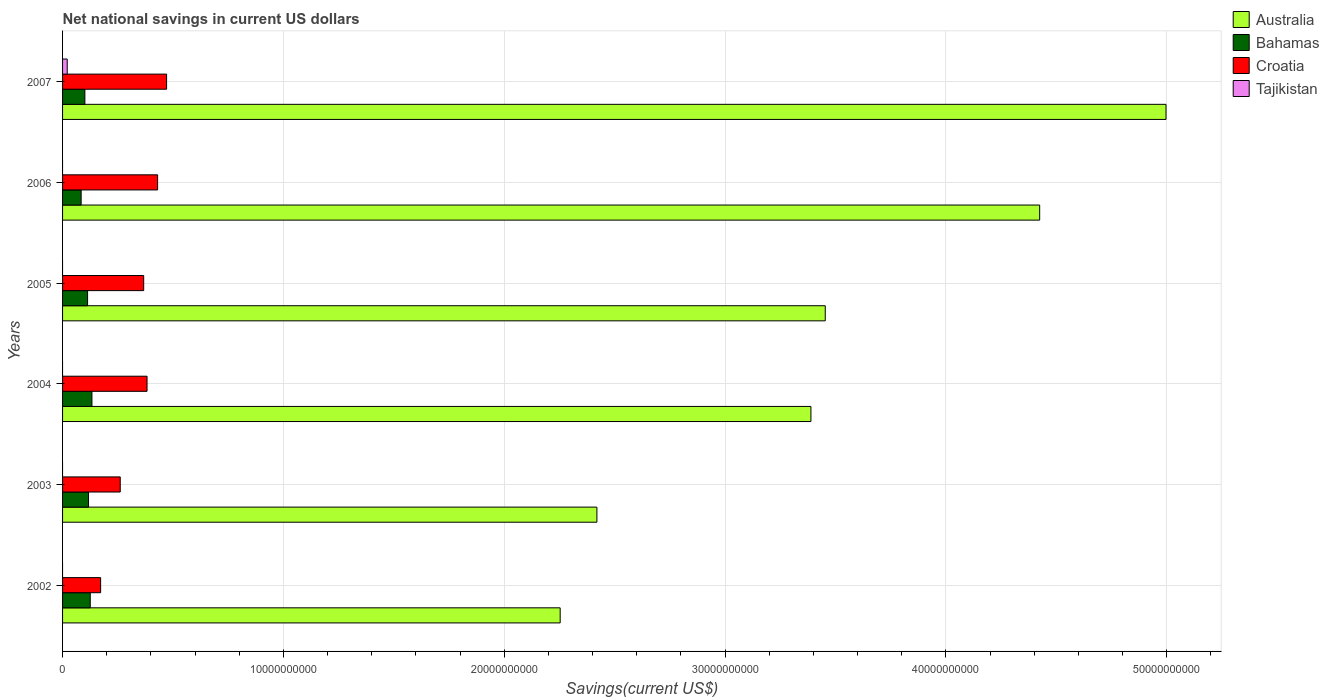Are the number of bars per tick equal to the number of legend labels?
Ensure brevity in your answer.  No. Are the number of bars on each tick of the Y-axis equal?
Offer a terse response. No. How many bars are there on the 4th tick from the top?
Offer a terse response. 3. How many bars are there on the 1st tick from the bottom?
Your answer should be very brief. 3. What is the label of the 5th group of bars from the top?
Provide a succinct answer. 2003. What is the net national savings in Croatia in 2007?
Give a very brief answer. 4.71e+09. Across all years, what is the maximum net national savings in Bahamas?
Provide a short and direct response. 1.33e+09. Across all years, what is the minimum net national savings in Bahamas?
Your answer should be very brief. 8.41e+08. In which year was the net national savings in Tajikistan maximum?
Keep it short and to the point. 2007. What is the total net national savings in Croatia in the graph?
Your answer should be very brief. 2.08e+1. What is the difference between the net national savings in Australia in 2002 and that in 2004?
Your answer should be very brief. -1.14e+1. What is the difference between the net national savings in Tajikistan in 2004 and the net national savings in Croatia in 2002?
Make the answer very short. -1.72e+09. What is the average net national savings in Tajikistan per year?
Your answer should be very brief. 3.51e+07. In the year 2004, what is the difference between the net national savings in Bahamas and net national savings in Australia?
Ensure brevity in your answer.  -3.26e+1. What is the ratio of the net national savings in Australia in 2003 to that in 2004?
Provide a succinct answer. 0.71. Is the difference between the net national savings in Bahamas in 2006 and 2007 greater than the difference between the net national savings in Australia in 2006 and 2007?
Make the answer very short. Yes. What is the difference between the highest and the second highest net national savings in Croatia?
Your response must be concise. 4.07e+08. What is the difference between the highest and the lowest net national savings in Tajikistan?
Your answer should be very brief. 2.11e+08. In how many years, is the net national savings in Tajikistan greater than the average net national savings in Tajikistan taken over all years?
Your answer should be very brief. 1. Is the sum of the net national savings in Croatia in 2006 and 2007 greater than the maximum net national savings in Bahamas across all years?
Your response must be concise. Yes. Are all the bars in the graph horizontal?
Make the answer very short. Yes. How many years are there in the graph?
Ensure brevity in your answer.  6. Are the values on the major ticks of X-axis written in scientific E-notation?
Your response must be concise. No. Where does the legend appear in the graph?
Offer a very short reply. Top right. What is the title of the graph?
Offer a very short reply. Net national savings in current US dollars. What is the label or title of the X-axis?
Provide a succinct answer. Savings(current US$). What is the Savings(current US$) in Australia in 2002?
Give a very brief answer. 2.25e+1. What is the Savings(current US$) of Bahamas in 2002?
Your answer should be very brief. 1.25e+09. What is the Savings(current US$) in Croatia in 2002?
Offer a terse response. 1.72e+09. What is the Savings(current US$) in Tajikistan in 2002?
Provide a short and direct response. 0. What is the Savings(current US$) in Australia in 2003?
Your answer should be compact. 2.42e+1. What is the Savings(current US$) of Bahamas in 2003?
Keep it short and to the point. 1.18e+09. What is the Savings(current US$) of Croatia in 2003?
Make the answer very short. 2.61e+09. What is the Savings(current US$) of Australia in 2004?
Keep it short and to the point. 3.39e+1. What is the Savings(current US$) in Bahamas in 2004?
Provide a succinct answer. 1.33e+09. What is the Savings(current US$) in Croatia in 2004?
Provide a short and direct response. 3.83e+09. What is the Savings(current US$) of Tajikistan in 2004?
Provide a short and direct response. 0. What is the Savings(current US$) in Australia in 2005?
Your answer should be compact. 3.45e+1. What is the Savings(current US$) of Bahamas in 2005?
Provide a short and direct response. 1.13e+09. What is the Savings(current US$) of Croatia in 2005?
Provide a short and direct response. 3.67e+09. What is the Savings(current US$) in Australia in 2006?
Provide a short and direct response. 4.42e+1. What is the Savings(current US$) of Bahamas in 2006?
Your answer should be compact. 8.41e+08. What is the Savings(current US$) of Croatia in 2006?
Provide a short and direct response. 4.30e+09. What is the Savings(current US$) in Australia in 2007?
Provide a succinct answer. 5.00e+1. What is the Savings(current US$) in Bahamas in 2007?
Your answer should be compact. 1.01e+09. What is the Savings(current US$) of Croatia in 2007?
Your answer should be very brief. 4.71e+09. What is the Savings(current US$) of Tajikistan in 2007?
Offer a very short reply. 2.11e+08. Across all years, what is the maximum Savings(current US$) of Australia?
Make the answer very short. 5.00e+1. Across all years, what is the maximum Savings(current US$) of Bahamas?
Your response must be concise. 1.33e+09. Across all years, what is the maximum Savings(current US$) of Croatia?
Provide a short and direct response. 4.71e+09. Across all years, what is the maximum Savings(current US$) in Tajikistan?
Make the answer very short. 2.11e+08. Across all years, what is the minimum Savings(current US$) in Australia?
Keep it short and to the point. 2.25e+1. Across all years, what is the minimum Savings(current US$) in Bahamas?
Make the answer very short. 8.41e+08. Across all years, what is the minimum Savings(current US$) in Croatia?
Your answer should be compact. 1.72e+09. Across all years, what is the minimum Savings(current US$) of Tajikistan?
Your response must be concise. 0. What is the total Savings(current US$) of Australia in the graph?
Make the answer very short. 2.09e+11. What is the total Savings(current US$) in Bahamas in the graph?
Your answer should be very brief. 6.74e+09. What is the total Savings(current US$) of Croatia in the graph?
Provide a succinct answer. 2.08e+1. What is the total Savings(current US$) in Tajikistan in the graph?
Your answer should be compact. 2.11e+08. What is the difference between the Savings(current US$) in Australia in 2002 and that in 2003?
Ensure brevity in your answer.  -1.66e+09. What is the difference between the Savings(current US$) in Bahamas in 2002 and that in 2003?
Give a very brief answer. 7.74e+07. What is the difference between the Savings(current US$) of Croatia in 2002 and that in 2003?
Provide a succinct answer. -8.88e+08. What is the difference between the Savings(current US$) in Australia in 2002 and that in 2004?
Your response must be concise. -1.14e+1. What is the difference between the Savings(current US$) of Bahamas in 2002 and that in 2004?
Provide a short and direct response. -7.68e+07. What is the difference between the Savings(current US$) in Croatia in 2002 and that in 2004?
Offer a terse response. -2.10e+09. What is the difference between the Savings(current US$) of Australia in 2002 and that in 2005?
Make the answer very short. -1.20e+1. What is the difference between the Savings(current US$) of Bahamas in 2002 and that in 2005?
Offer a terse response. 1.21e+08. What is the difference between the Savings(current US$) of Croatia in 2002 and that in 2005?
Your answer should be very brief. -1.95e+09. What is the difference between the Savings(current US$) of Australia in 2002 and that in 2006?
Keep it short and to the point. -2.17e+1. What is the difference between the Savings(current US$) of Bahamas in 2002 and that in 2006?
Offer a terse response. 4.12e+08. What is the difference between the Savings(current US$) in Croatia in 2002 and that in 2006?
Provide a succinct answer. -2.58e+09. What is the difference between the Savings(current US$) of Australia in 2002 and that in 2007?
Provide a succinct answer. -2.74e+1. What is the difference between the Savings(current US$) of Bahamas in 2002 and that in 2007?
Ensure brevity in your answer.  2.43e+08. What is the difference between the Savings(current US$) of Croatia in 2002 and that in 2007?
Offer a very short reply. -2.99e+09. What is the difference between the Savings(current US$) of Australia in 2003 and that in 2004?
Your answer should be compact. -9.69e+09. What is the difference between the Savings(current US$) of Bahamas in 2003 and that in 2004?
Your response must be concise. -1.54e+08. What is the difference between the Savings(current US$) in Croatia in 2003 and that in 2004?
Make the answer very short. -1.21e+09. What is the difference between the Savings(current US$) of Australia in 2003 and that in 2005?
Offer a very short reply. -1.03e+1. What is the difference between the Savings(current US$) in Bahamas in 2003 and that in 2005?
Your response must be concise. 4.34e+07. What is the difference between the Savings(current US$) of Croatia in 2003 and that in 2005?
Your response must be concise. -1.06e+09. What is the difference between the Savings(current US$) of Australia in 2003 and that in 2006?
Offer a very short reply. -2.01e+1. What is the difference between the Savings(current US$) of Bahamas in 2003 and that in 2006?
Offer a terse response. 3.35e+08. What is the difference between the Savings(current US$) in Croatia in 2003 and that in 2006?
Offer a terse response. -1.69e+09. What is the difference between the Savings(current US$) of Australia in 2003 and that in 2007?
Offer a terse response. -2.58e+1. What is the difference between the Savings(current US$) in Bahamas in 2003 and that in 2007?
Ensure brevity in your answer.  1.66e+08. What is the difference between the Savings(current US$) of Croatia in 2003 and that in 2007?
Offer a terse response. -2.10e+09. What is the difference between the Savings(current US$) of Australia in 2004 and that in 2005?
Your answer should be very brief. -6.49e+08. What is the difference between the Savings(current US$) of Bahamas in 2004 and that in 2005?
Provide a short and direct response. 1.98e+08. What is the difference between the Savings(current US$) of Croatia in 2004 and that in 2005?
Provide a short and direct response. 1.52e+08. What is the difference between the Savings(current US$) in Australia in 2004 and that in 2006?
Keep it short and to the point. -1.04e+1. What is the difference between the Savings(current US$) in Bahamas in 2004 and that in 2006?
Your response must be concise. 4.89e+08. What is the difference between the Savings(current US$) in Croatia in 2004 and that in 2006?
Your response must be concise. -4.78e+08. What is the difference between the Savings(current US$) in Australia in 2004 and that in 2007?
Your answer should be compact. -1.61e+1. What is the difference between the Savings(current US$) of Bahamas in 2004 and that in 2007?
Give a very brief answer. 3.20e+08. What is the difference between the Savings(current US$) in Croatia in 2004 and that in 2007?
Provide a succinct answer. -8.85e+08. What is the difference between the Savings(current US$) in Australia in 2005 and that in 2006?
Offer a very short reply. -9.71e+09. What is the difference between the Savings(current US$) of Bahamas in 2005 and that in 2006?
Your answer should be compact. 2.91e+08. What is the difference between the Savings(current US$) in Croatia in 2005 and that in 2006?
Provide a succinct answer. -6.30e+08. What is the difference between the Savings(current US$) of Australia in 2005 and that in 2007?
Keep it short and to the point. -1.54e+1. What is the difference between the Savings(current US$) in Bahamas in 2005 and that in 2007?
Your response must be concise. 1.22e+08. What is the difference between the Savings(current US$) in Croatia in 2005 and that in 2007?
Your answer should be compact. -1.04e+09. What is the difference between the Savings(current US$) in Australia in 2006 and that in 2007?
Your answer should be very brief. -5.72e+09. What is the difference between the Savings(current US$) in Bahamas in 2006 and that in 2007?
Keep it short and to the point. -1.69e+08. What is the difference between the Savings(current US$) in Croatia in 2006 and that in 2007?
Provide a short and direct response. -4.07e+08. What is the difference between the Savings(current US$) of Australia in 2002 and the Savings(current US$) of Bahamas in 2003?
Provide a succinct answer. 2.14e+1. What is the difference between the Savings(current US$) in Australia in 2002 and the Savings(current US$) in Croatia in 2003?
Offer a terse response. 1.99e+1. What is the difference between the Savings(current US$) in Bahamas in 2002 and the Savings(current US$) in Croatia in 2003?
Give a very brief answer. -1.36e+09. What is the difference between the Savings(current US$) in Australia in 2002 and the Savings(current US$) in Bahamas in 2004?
Your response must be concise. 2.12e+1. What is the difference between the Savings(current US$) of Australia in 2002 and the Savings(current US$) of Croatia in 2004?
Your answer should be very brief. 1.87e+1. What is the difference between the Savings(current US$) of Bahamas in 2002 and the Savings(current US$) of Croatia in 2004?
Offer a terse response. -2.57e+09. What is the difference between the Savings(current US$) of Australia in 2002 and the Savings(current US$) of Bahamas in 2005?
Your answer should be very brief. 2.14e+1. What is the difference between the Savings(current US$) in Australia in 2002 and the Savings(current US$) in Croatia in 2005?
Your response must be concise. 1.89e+1. What is the difference between the Savings(current US$) in Bahamas in 2002 and the Savings(current US$) in Croatia in 2005?
Keep it short and to the point. -2.42e+09. What is the difference between the Savings(current US$) in Australia in 2002 and the Savings(current US$) in Bahamas in 2006?
Provide a short and direct response. 2.17e+1. What is the difference between the Savings(current US$) of Australia in 2002 and the Savings(current US$) of Croatia in 2006?
Keep it short and to the point. 1.82e+1. What is the difference between the Savings(current US$) in Bahamas in 2002 and the Savings(current US$) in Croatia in 2006?
Ensure brevity in your answer.  -3.05e+09. What is the difference between the Savings(current US$) in Australia in 2002 and the Savings(current US$) in Bahamas in 2007?
Give a very brief answer. 2.15e+1. What is the difference between the Savings(current US$) of Australia in 2002 and the Savings(current US$) of Croatia in 2007?
Keep it short and to the point. 1.78e+1. What is the difference between the Savings(current US$) in Australia in 2002 and the Savings(current US$) in Tajikistan in 2007?
Give a very brief answer. 2.23e+1. What is the difference between the Savings(current US$) in Bahamas in 2002 and the Savings(current US$) in Croatia in 2007?
Offer a terse response. -3.46e+09. What is the difference between the Savings(current US$) in Bahamas in 2002 and the Savings(current US$) in Tajikistan in 2007?
Ensure brevity in your answer.  1.04e+09. What is the difference between the Savings(current US$) in Croatia in 2002 and the Savings(current US$) in Tajikistan in 2007?
Provide a succinct answer. 1.51e+09. What is the difference between the Savings(current US$) in Australia in 2003 and the Savings(current US$) in Bahamas in 2004?
Your answer should be very brief. 2.29e+1. What is the difference between the Savings(current US$) in Australia in 2003 and the Savings(current US$) in Croatia in 2004?
Your answer should be very brief. 2.04e+1. What is the difference between the Savings(current US$) of Bahamas in 2003 and the Savings(current US$) of Croatia in 2004?
Your answer should be very brief. -2.65e+09. What is the difference between the Savings(current US$) of Australia in 2003 and the Savings(current US$) of Bahamas in 2005?
Your response must be concise. 2.31e+1. What is the difference between the Savings(current US$) of Australia in 2003 and the Savings(current US$) of Croatia in 2005?
Provide a succinct answer. 2.05e+1. What is the difference between the Savings(current US$) of Bahamas in 2003 and the Savings(current US$) of Croatia in 2005?
Your answer should be very brief. -2.50e+09. What is the difference between the Savings(current US$) of Australia in 2003 and the Savings(current US$) of Bahamas in 2006?
Ensure brevity in your answer.  2.34e+1. What is the difference between the Savings(current US$) of Australia in 2003 and the Savings(current US$) of Croatia in 2006?
Provide a succinct answer. 1.99e+1. What is the difference between the Savings(current US$) in Bahamas in 2003 and the Savings(current US$) in Croatia in 2006?
Your answer should be compact. -3.13e+09. What is the difference between the Savings(current US$) of Australia in 2003 and the Savings(current US$) of Bahamas in 2007?
Give a very brief answer. 2.32e+1. What is the difference between the Savings(current US$) in Australia in 2003 and the Savings(current US$) in Croatia in 2007?
Keep it short and to the point. 1.95e+1. What is the difference between the Savings(current US$) of Australia in 2003 and the Savings(current US$) of Tajikistan in 2007?
Make the answer very short. 2.40e+1. What is the difference between the Savings(current US$) of Bahamas in 2003 and the Savings(current US$) of Croatia in 2007?
Keep it short and to the point. -3.53e+09. What is the difference between the Savings(current US$) in Bahamas in 2003 and the Savings(current US$) in Tajikistan in 2007?
Make the answer very short. 9.65e+08. What is the difference between the Savings(current US$) of Croatia in 2003 and the Savings(current US$) of Tajikistan in 2007?
Give a very brief answer. 2.40e+09. What is the difference between the Savings(current US$) in Australia in 2004 and the Savings(current US$) in Bahamas in 2005?
Your answer should be compact. 3.28e+1. What is the difference between the Savings(current US$) in Australia in 2004 and the Savings(current US$) in Croatia in 2005?
Give a very brief answer. 3.02e+1. What is the difference between the Savings(current US$) of Bahamas in 2004 and the Savings(current US$) of Croatia in 2005?
Make the answer very short. -2.34e+09. What is the difference between the Savings(current US$) in Australia in 2004 and the Savings(current US$) in Bahamas in 2006?
Your response must be concise. 3.30e+1. What is the difference between the Savings(current US$) in Australia in 2004 and the Savings(current US$) in Croatia in 2006?
Ensure brevity in your answer.  2.96e+1. What is the difference between the Savings(current US$) in Bahamas in 2004 and the Savings(current US$) in Croatia in 2006?
Ensure brevity in your answer.  -2.97e+09. What is the difference between the Savings(current US$) of Australia in 2004 and the Savings(current US$) of Bahamas in 2007?
Provide a short and direct response. 3.29e+1. What is the difference between the Savings(current US$) of Australia in 2004 and the Savings(current US$) of Croatia in 2007?
Ensure brevity in your answer.  2.92e+1. What is the difference between the Savings(current US$) of Australia in 2004 and the Savings(current US$) of Tajikistan in 2007?
Offer a terse response. 3.37e+1. What is the difference between the Savings(current US$) of Bahamas in 2004 and the Savings(current US$) of Croatia in 2007?
Your answer should be very brief. -3.38e+09. What is the difference between the Savings(current US$) in Bahamas in 2004 and the Savings(current US$) in Tajikistan in 2007?
Provide a succinct answer. 1.12e+09. What is the difference between the Savings(current US$) in Croatia in 2004 and the Savings(current US$) in Tajikistan in 2007?
Provide a short and direct response. 3.61e+09. What is the difference between the Savings(current US$) in Australia in 2005 and the Savings(current US$) in Bahamas in 2006?
Your response must be concise. 3.37e+1. What is the difference between the Savings(current US$) in Australia in 2005 and the Savings(current US$) in Croatia in 2006?
Give a very brief answer. 3.02e+1. What is the difference between the Savings(current US$) in Bahamas in 2005 and the Savings(current US$) in Croatia in 2006?
Provide a short and direct response. -3.17e+09. What is the difference between the Savings(current US$) of Australia in 2005 and the Savings(current US$) of Bahamas in 2007?
Give a very brief answer. 3.35e+1. What is the difference between the Savings(current US$) of Australia in 2005 and the Savings(current US$) of Croatia in 2007?
Make the answer very short. 2.98e+1. What is the difference between the Savings(current US$) of Australia in 2005 and the Savings(current US$) of Tajikistan in 2007?
Make the answer very short. 3.43e+1. What is the difference between the Savings(current US$) of Bahamas in 2005 and the Savings(current US$) of Croatia in 2007?
Provide a short and direct response. -3.58e+09. What is the difference between the Savings(current US$) in Bahamas in 2005 and the Savings(current US$) in Tajikistan in 2007?
Keep it short and to the point. 9.22e+08. What is the difference between the Savings(current US$) of Croatia in 2005 and the Savings(current US$) of Tajikistan in 2007?
Keep it short and to the point. 3.46e+09. What is the difference between the Savings(current US$) of Australia in 2006 and the Savings(current US$) of Bahamas in 2007?
Keep it short and to the point. 4.32e+1. What is the difference between the Savings(current US$) of Australia in 2006 and the Savings(current US$) of Croatia in 2007?
Ensure brevity in your answer.  3.95e+1. What is the difference between the Savings(current US$) of Australia in 2006 and the Savings(current US$) of Tajikistan in 2007?
Offer a terse response. 4.40e+1. What is the difference between the Savings(current US$) of Bahamas in 2006 and the Savings(current US$) of Croatia in 2007?
Keep it short and to the point. -3.87e+09. What is the difference between the Savings(current US$) in Bahamas in 2006 and the Savings(current US$) in Tajikistan in 2007?
Give a very brief answer. 6.31e+08. What is the difference between the Savings(current US$) in Croatia in 2006 and the Savings(current US$) in Tajikistan in 2007?
Offer a very short reply. 4.09e+09. What is the average Savings(current US$) of Australia per year?
Your answer should be very brief. 3.49e+1. What is the average Savings(current US$) of Bahamas per year?
Your response must be concise. 1.12e+09. What is the average Savings(current US$) of Croatia per year?
Make the answer very short. 3.47e+09. What is the average Savings(current US$) in Tajikistan per year?
Ensure brevity in your answer.  3.51e+07. In the year 2002, what is the difference between the Savings(current US$) in Australia and Savings(current US$) in Bahamas?
Provide a short and direct response. 2.13e+1. In the year 2002, what is the difference between the Savings(current US$) in Australia and Savings(current US$) in Croatia?
Offer a terse response. 2.08e+1. In the year 2002, what is the difference between the Savings(current US$) of Bahamas and Savings(current US$) of Croatia?
Ensure brevity in your answer.  -4.70e+08. In the year 2003, what is the difference between the Savings(current US$) in Australia and Savings(current US$) in Bahamas?
Your answer should be very brief. 2.30e+1. In the year 2003, what is the difference between the Savings(current US$) in Australia and Savings(current US$) in Croatia?
Make the answer very short. 2.16e+1. In the year 2003, what is the difference between the Savings(current US$) of Bahamas and Savings(current US$) of Croatia?
Your answer should be very brief. -1.44e+09. In the year 2004, what is the difference between the Savings(current US$) of Australia and Savings(current US$) of Bahamas?
Your answer should be very brief. 3.26e+1. In the year 2004, what is the difference between the Savings(current US$) in Australia and Savings(current US$) in Croatia?
Keep it short and to the point. 3.01e+1. In the year 2004, what is the difference between the Savings(current US$) of Bahamas and Savings(current US$) of Croatia?
Offer a very short reply. -2.50e+09. In the year 2005, what is the difference between the Savings(current US$) of Australia and Savings(current US$) of Bahamas?
Provide a short and direct response. 3.34e+1. In the year 2005, what is the difference between the Savings(current US$) in Australia and Savings(current US$) in Croatia?
Make the answer very short. 3.09e+1. In the year 2005, what is the difference between the Savings(current US$) of Bahamas and Savings(current US$) of Croatia?
Make the answer very short. -2.54e+09. In the year 2006, what is the difference between the Savings(current US$) of Australia and Savings(current US$) of Bahamas?
Your response must be concise. 4.34e+1. In the year 2006, what is the difference between the Savings(current US$) of Australia and Savings(current US$) of Croatia?
Offer a terse response. 3.99e+1. In the year 2006, what is the difference between the Savings(current US$) in Bahamas and Savings(current US$) in Croatia?
Provide a succinct answer. -3.46e+09. In the year 2007, what is the difference between the Savings(current US$) in Australia and Savings(current US$) in Bahamas?
Your response must be concise. 4.90e+1. In the year 2007, what is the difference between the Savings(current US$) in Australia and Savings(current US$) in Croatia?
Your answer should be compact. 4.53e+1. In the year 2007, what is the difference between the Savings(current US$) of Australia and Savings(current US$) of Tajikistan?
Make the answer very short. 4.98e+1. In the year 2007, what is the difference between the Savings(current US$) of Bahamas and Savings(current US$) of Croatia?
Your answer should be very brief. -3.70e+09. In the year 2007, what is the difference between the Savings(current US$) in Bahamas and Savings(current US$) in Tajikistan?
Ensure brevity in your answer.  8.00e+08. In the year 2007, what is the difference between the Savings(current US$) of Croatia and Savings(current US$) of Tajikistan?
Keep it short and to the point. 4.50e+09. What is the ratio of the Savings(current US$) in Australia in 2002 to that in 2003?
Ensure brevity in your answer.  0.93. What is the ratio of the Savings(current US$) of Bahamas in 2002 to that in 2003?
Provide a short and direct response. 1.07. What is the ratio of the Savings(current US$) of Croatia in 2002 to that in 2003?
Ensure brevity in your answer.  0.66. What is the ratio of the Savings(current US$) in Australia in 2002 to that in 2004?
Your response must be concise. 0.66. What is the ratio of the Savings(current US$) in Bahamas in 2002 to that in 2004?
Ensure brevity in your answer.  0.94. What is the ratio of the Savings(current US$) of Croatia in 2002 to that in 2004?
Your answer should be very brief. 0.45. What is the ratio of the Savings(current US$) in Australia in 2002 to that in 2005?
Your answer should be very brief. 0.65. What is the ratio of the Savings(current US$) of Bahamas in 2002 to that in 2005?
Provide a succinct answer. 1.11. What is the ratio of the Savings(current US$) of Croatia in 2002 to that in 2005?
Your response must be concise. 0.47. What is the ratio of the Savings(current US$) in Australia in 2002 to that in 2006?
Provide a short and direct response. 0.51. What is the ratio of the Savings(current US$) of Bahamas in 2002 to that in 2006?
Ensure brevity in your answer.  1.49. What is the ratio of the Savings(current US$) of Croatia in 2002 to that in 2006?
Your answer should be compact. 0.4. What is the ratio of the Savings(current US$) of Australia in 2002 to that in 2007?
Provide a succinct answer. 0.45. What is the ratio of the Savings(current US$) of Bahamas in 2002 to that in 2007?
Provide a succinct answer. 1.24. What is the ratio of the Savings(current US$) of Croatia in 2002 to that in 2007?
Ensure brevity in your answer.  0.37. What is the ratio of the Savings(current US$) in Australia in 2003 to that in 2004?
Provide a succinct answer. 0.71. What is the ratio of the Savings(current US$) of Bahamas in 2003 to that in 2004?
Keep it short and to the point. 0.88. What is the ratio of the Savings(current US$) of Croatia in 2003 to that in 2004?
Your answer should be very brief. 0.68. What is the ratio of the Savings(current US$) of Australia in 2003 to that in 2005?
Keep it short and to the point. 0.7. What is the ratio of the Savings(current US$) of Bahamas in 2003 to that in 2005?
Your answer should be very brief. 1.04. What is the ratio of the Savings(current US$) in Croatia in 2003 to that in 2005?
Offer a very short reply. 0.71. What is the ratio of the Savings(current US$) of Australia in 2003 to that in 2006?
Keep it short and to the point. 0.55. What is the ratio of the Savings(current US$) in Bahamas in 2003 to that in 2006?
Offer a very short reply. 1.4. What is the ratio of the Savings(current US$) in Croatia in 2003 to that in 2006?
Your response must be concise. 0.61. What is the ratio of the Savings(current US$) of Australia in 2003 to that in 2007?
Provide a short and direct response. 0.48. What is the ratio of the Savings(current US$) in Bahamas in 2003 to that in 2007?
Provide a short and direct response. 1.16. What is the ratio of the Savings(current US$) in Croatia in 2003 to that in 2007?
Provide a succinct answer. 0.55. What is the ratio of the Savings(current US$) of Australia in 2004 to that in 2005?
Provide a short and direct response. 0.98. What is the ratio of the Savings(current US$) in Bahamas in 2004 to that in 2005?
Offer a very short reply. 1.17. What is the ratio of the Savings(current US$) in Croatia in 2004 to that in 2005?
Your response must be concise. 1.04. What is the ratio of the Savings(current US$) in Australia in 2004 to that in 2006?
Your answer should be compact. 0.77. What is the ratio of the Savings(current US$) in Bahamas in 2004 to that in 2006?
Offer a very short reply. 1.58. What is the ratio of the Savings(current US$) of Croatia in 2004 to that in 2006?
Offer a very short reply. 0.89. What is the ratio of the Savings(current US$) in Australia in 2004 to that in 2007?
Provide a short and direct response. 0.68. What is the ratio of the Savings(current US$) of Bahamas in 2004 to that in 2007?
Your response must be concise. 1.32. What is the ratio of the Savings(current US$) in Croatia in 2004 to that in 2007?
Keep it short and to the point. 0.81. What is the ratio of the Savings(current US$) in Australia in 2005 to that in 2006?
Provide a short and direct response. 0.78. What is the ratio of the Savings(current US$) of Bahamas in 2005 to that in 2006?
Offer a terse response. 1.35. What is the ratio of the Savings(current US$) of Croatia in 2005 to that in 2006?
Your answer should be compact. 0.85. What is the ratio of the Savings(current US$) of Australia in 2005 to that in 2007?
Provide a succinct answer. 0.69. What is the ratio of the Savings(current US$) of Bahamas in 2005 to that in 2007?
Your answer should be very brief. 1.12. What is the ratio of the Savings(current US$) of Croatia in 2005 to that in 2007?
Keep it short and to the point. 0.78. What is the ratio of the Savings(current US$) in Australia in 2006 to that in 2007?
Your response must be concise. 0.89. What is the ratio of the Savings(current US$) of Bahamas in 2006 to that in 2007?
Your answer should be compact. 0.83. What is the ratio of the Savings(current US$) in Croatia in 2006 to that in 2007?
Provide a succinct answer. 0.91. What is the difference between the highest and the second highest Savings(current US$) in Australia?
Your response must be concise. 5.72e+09. What is the difference between the highest and the second highest Savings(current US$) of Bahamas?
Keep it short and to the point. 7.68e+07. What is the difference between the highest and the second highest Savings(current US$) of Croatia?
Your answer should be compact. 4.07e+08. What is the difference between the highest and the lowest Savings(current US$) in Australia?
Your answer should be compact. 2.74e+1. What is the difference between the highest and the lowest Savings(current US$) of Bahamas?
Offer a very short reply. 4.89e+08. What is the difference between the highest and the lowest Savings(current US$) of Croatia?
Your response must be concise. 2.99e+09. What is the difference between the highest and the lowest Savings(current US$) in Tajikistan?
Your response must be concise. 2.11e+08. 